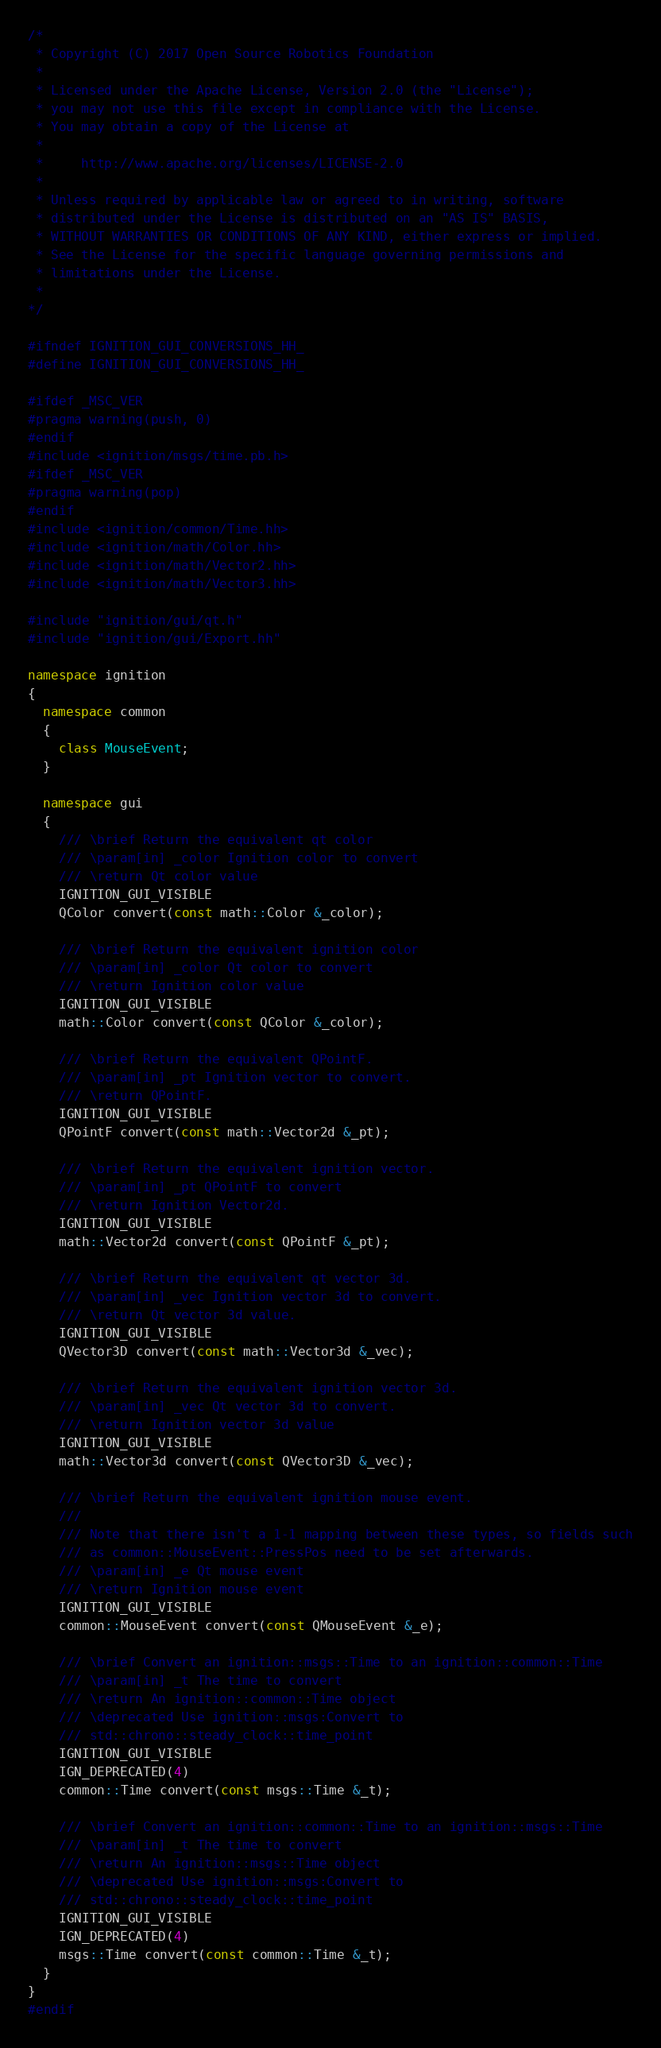<code> <loc_0><loc_0><loc_500><loc_500><_C++_>/*
 * Copyright (C) 2017 Open Source Robotics Foundation
 *
 * Licensed under the Apache License, Version 2.0 (the "License");
 * you may not use this file except in compliance with the License.
 * You may obtain a copy of the License at
 *
 *     http://www.apache.org/licenses/LICENSE-2.0
 *
 * Unless required by applicable law or agreed to in writing, software
 * distributed under the License is distributed on an "AS IS" BASIS,
 * WITHOUT WARRANTIES OR CONDITIONS OF ANY KIND, either express or implied.
 * See the License for the specific language governing permissions and
 * limitations under the License.
 *
*/

#ifndef IGNITION_GUI_CONVERSIONS_HH_
#define IGNITION_GUI_CONVERSIONS_HH_

#ifdef _MSC_VER
#pragma warning(push, 0)
#endif
#include <ignition/msgs/time.pb.h>
#ifdef _MSC_VER
#pragma warning(pop)
#endif
#include <ignition/common/Time.hh>
#include <ignition/math/Color.hh>
#include <ignition/math/Vector2.hh>
#include <ignition/math/Vector3.hh>

#include "ignition/gui/qt.h"
#include "ignition/gui/Export.hh"

namespace ignition
{
  namespace common
  {
    class MouseEvent;
  }

  namespace gui
  {
    /// \brief Return the equivalent qt color
    /// \param[in] _color Ignition color to convert
    /// \return Qt color value
    IGNITION_GUI_VISIBLE
    QColor convert(const math::Color &_color);

    /// \brief Return the equivalent ignition color
    /// \param[in] _color Qt color to convert
    /// \return Ignition color value
    IGNITION_GUI_VISIBLE
    math::Color convert(const QColor &_color);

    /// \brief Return the equivalent QPointF.
    /// \param[in] _pt Ignition vector to convert.
    /// \return QPointF.
    IGNITION_GUI_VISIBLE
    QPointF convert(const math::Vector2d &_pt);

    /// \brief Return the equivalent ignition vector.
    /// \param[in] _pt QPointF to convert
    /// \return Ignition Vector2d.
    IGNITION_GUI_VISIBLE
    math::Vector2d convert(const QPointF &_pt);

    /// \brief Return the equivalent qt vector 3d.
    /// \param[in] _vec Ignition vector 3d to convert.
    /// \return Qt vector 3d value.
    IGNITION_GUI_VISIBLE
    QVector3D convert(const math::Vector3d &_vec);

    /// \brief Return the equivalent ignition vector 3d.
    /// \param[in] _vec Qt vector 3d to convert.
    /// \return Ignition vector 3d value
    IGNITION_GUI_VISIBLE
    math::Vector3d convert(const QVector3D &_vec);

    /// \brief Return the equivalent ignition mouse event.
    ///
    /// Note that there isn't a 1-1 mapping between these types, so fields such
    /// as common::MouseEvent::PressPos need to be set afterwards.
    /// \param[in] _e Qt mouse event
    /// \return Ignition mouse event
    IGNITION_GUI_VISIBLE
    common::MouseEvent convert(const QMouseEvent &_e);

    /// \brief Convert an ignition::msgs::Time to an ignition::common::Time
    /// \param[in] _t The time to convert
    /// \return An ignition::common::Time object
    /// \deprecated Use ignition::msgs:Convert to
    /// std::chrono::steady_clock::time_point
    IGNITION_GUI_VISIBLE
    IGN_DEPRECATED(4)
    common::Time convert(const msgs::Time &_t);

    /// \brief Convert an ignition::common::Time to an ignition::msgs::Time
    /// \param[in] _t The time to convert
    /// \return An ignition::msgs::Time object
    /// \deprecated Use ignition::msgs:Convert to
    /// std::chrono::steady_clock::time_point
    IGNITION_GUI_VISIBLE
    IGN_DEPRECATED(4)
    msgs::Time convert(const common::Time &_t);
  }
}
#endif
</code> 